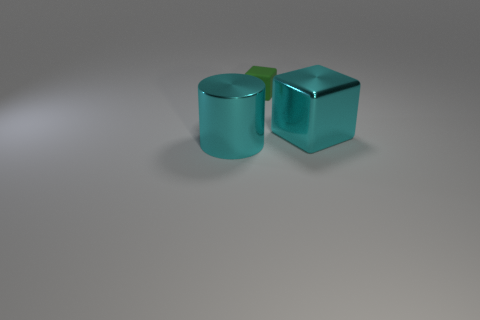How many big cyan things are to the left of the large metallic block and to the right of the small matte cube? 0 